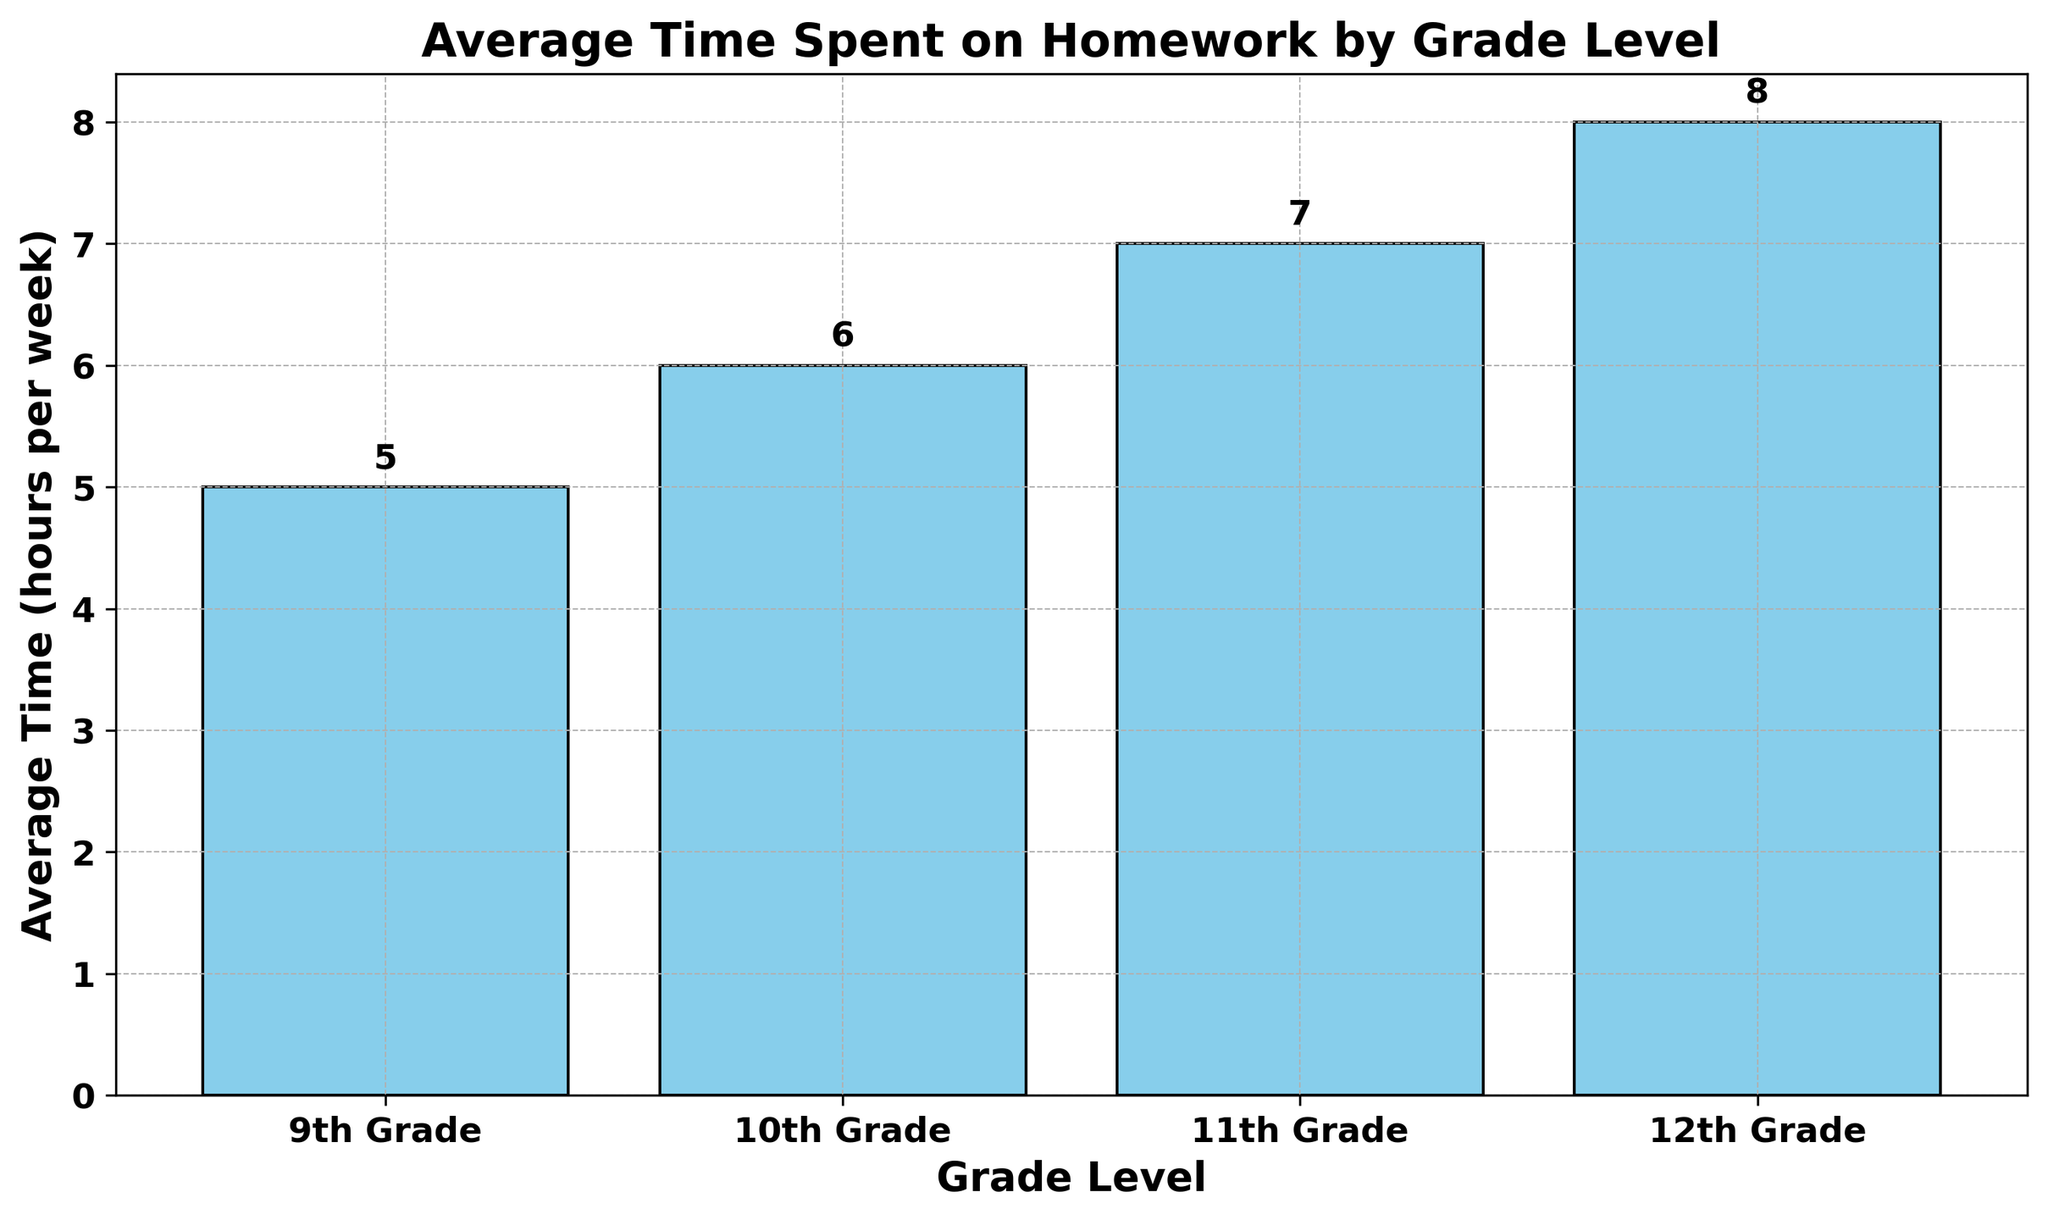What is the average time spent on homework by 10th Grade students? The 10th Grade bar in the chart reaches up to 6 hours.
Answer: 6 Which grade level spends the most time on homework? The tallest bar in the chart represents the 12th Grade, which corresponds to the highest average time spent on homework.
Answer: 12th Grade Which grade has a higher average time spent on homework: 9th Grade or 11th Grade? By comparing the heights of the bars for 9th Grade and 11th Grade, we can see that 11th Grade (7 hours) is higher than 9th Grade (5 hours).
Answer: 11th Grade What is the total average time spent on homework for all grade levels combined? Add the average times for each grade level: 5 (9th) + 6 (10th) + 7 (11th) + 8 (12th) = 26 hours.
Answer: 26 How much more time does the average 11th Grade student spend on homework compared to a 9th Grade student? Subtract the average time for 9th Grade from that of 11th Grade: 7 - 5 = 2 hours more.
Answer: 2 hours Which grade levels have an average homework time of 7 hours or more? By examining the bar heights, 11th Grade (7 hours) and 12th Grade (8 hours) fit this criteria.
Answer: 11th Grade and 12th Grade What is the difference in average homework time between the 12th Grade and the 10th Grade? Subtract the average time for 10th Grade from that of 12th Grade: 8 - 6 = 2 hours.
Answer: 2 hours Among 9th, 10th, and 11th Grade, which spends the least average time on homework? The shortest bar among these grades is 9th Grade (5 hours).
Answer: 9th Grade How does the average homework time change from 9th Grade to 12th Grade? The average time increases incrementally by 1 hour for each subsequent grade level: 9th (5) to 10th (6) to 11th (7) to 12th (8).
Answer: Increases by 1 hour per grade level 